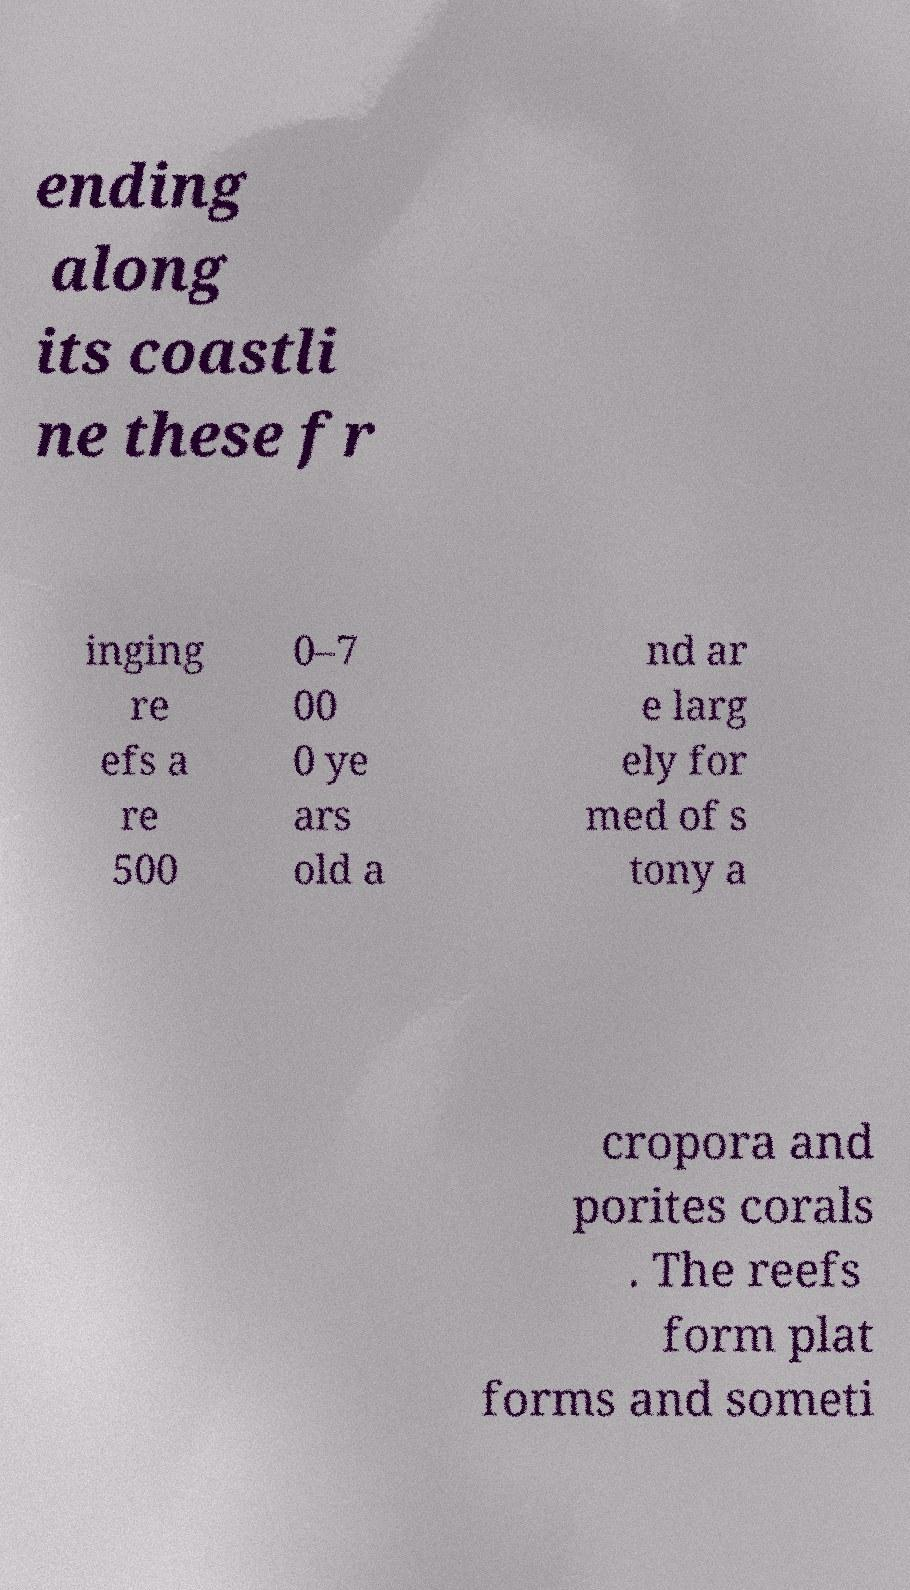I need the written content from this picture converted into text. Can you do that? ending along its coastli ne these fr inging re efs a re 500 0–7 00 0 ye ars old a nd ar e larg ely for med of s tony a cropora and porites corals . The reefs form plat forms and someti 